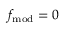<formula> <loc_0><loc_0><loc_500><loc_500>f _ { m o d } = 0</formula> 